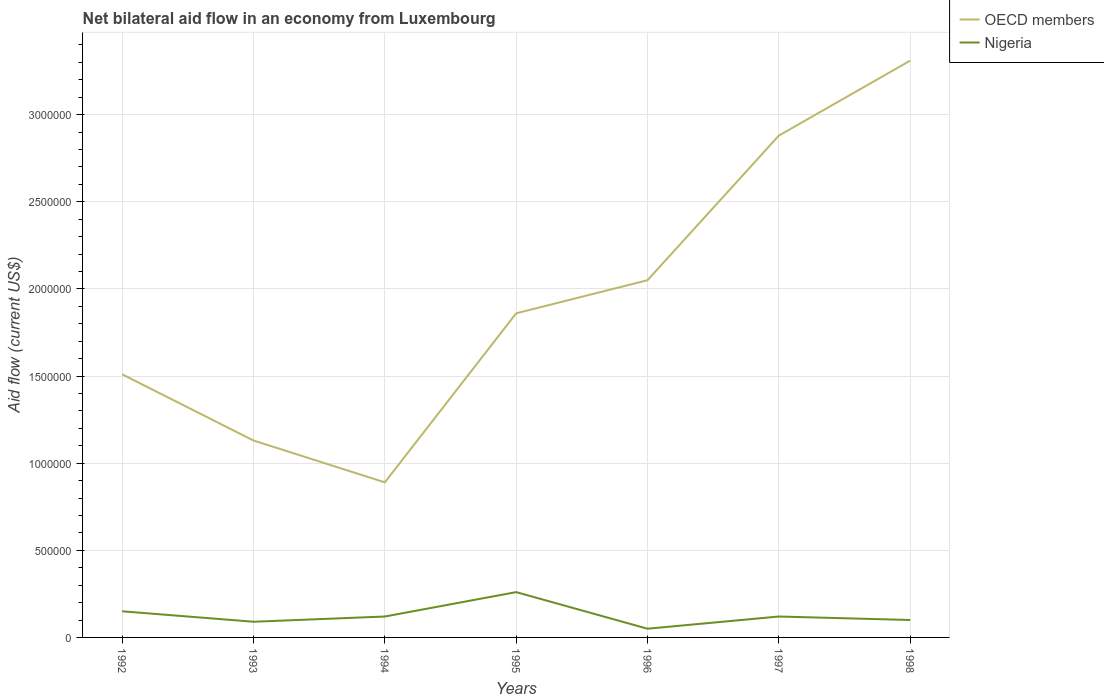How many different coloured lines are there?
Ensure brevity in your answer.  2. What is the total net bilateral aid flow in OECD members in the graph?
Make the answer very short. -1.99e+06. What is the difference between the highest and the second highest net bilateral aid flow in OECD members?
Keep it short and to the point. 2.42e+06. Is the net bilateral aid flow in OECD members strictly greater than the net bilateral aid flow in Nigeria over the years?
Offer a terse response. No. How many lines are there?
Ensure brevity in your answer.  2. Are the values on the major ticks of Y-axis written in scientific E-notation?
Provide a short and direct response. No. Does the graph contain any zero values?
Offer a terse response. No. Where does the legend appear in the graph?
Provide a succinct answer. Top right. How many legend labels are there?
Offer a terse response. 2. What is the title of the graph?
Provide a succinct answer. Net bilateral aid flow in an economy from Luxembourg. Does "Other small states" appear as one of the legend labels in the graph?
Your answer should be very brief. No. What is the label or title of the X-axis?
Offer a very short reply. Years. What is the label or title of the Y-axis?
Make the answer very short. Aid flow (current US$). What is the Aid flow (current US$) in OECD members in 1992?
Your answer should be compact. 1.51e+06. What is the Aid flow (current US$) of Nigeria in 1992?
Make the answer very short. 1.50e+05. What is the Aid flow (current US$) of OECD members in 1993?
Your answer should be very brief. 1.13e+06. What is the Aid flow (current US$) of Nigeria in 1993?
Keep it short and to the point. 9.00e+04. What is the Aid flow (current US$) of OECD members in 1994?
Provide a succinct answer. 8.90e+05. What is the Aid flow (current US$) of Nigeria in 1994?
Your answer should be compact. 1.20e+05. What is the Aid flow (current US$) of OECD members in 1995?
Ensure brevity in your answer.  1.86e+06. What is the Aid flow (current US$) in OECD members in 1996?
Provide a short and direct response. 2.05e+06. What is the Aid flow (current US$) of Nigeria in 1996?
Give a very brief answer. 5.00e+04. What is the Aid flow (current US$) of OECD members in 1997?
Offer a terse response. 2.88e+06. What is the Aid flow (current US$) in Nigeria in 1997?
Make the answer very short. 1.20e+05. What is the Aid flow (current US$) in OECD members in 1998?
Offer a terse response. 3.31e+06. What is the Aid flow (current US$) of Nigeria in 1998?
Ensure brevity in your answer.  1.00e+05. Across all years, what is the maximum Aid flow (current US$) of OECD members?
Your response must be concise. 3.31e+06. Across all years, what is the minimum Aid flow (current US$) in OECD members?
Offer a very short reply. 8.90e+05. Across all years, what is the minimum Aid flow (current US$) of Nigeria?
Keep it short and to the point. 5.00e+04. What is the total Aid flow (current US$) of OECD members in the graph?
Your answer should be very brief. 1.36e+07. What is the total Aid flow (current US$) in Nigeria in the graph?
Your answer should be very brief. 8.90e+05. What is the difference between the Aid flow (current US$) of OECD members in 1992 and that in 1994?
Offer a very short reply. 6.20e+05. What is the difference between the Aid flow (current US$) of OECD members in 1992 and that in 1995?
Your answer should be compact. -3.50e+05. What is the difference between the Aid flow (current US$) in Nigeria in 1992 and that in 1995?
Your answer should be compact. -1.10e+05. What is the difference between the Aid flow (current US$) in OECD members in 1992 and that in 1996?
Keep it short and to the point. -5.40e+05. What is the difference between the Aid flow (current US$) of OECD members in 1992 and that in 1997?
Ensure brevity in your answer.  -1.37e+06. What is the difference between the Aid flow (current US$) in OECD members in 1992 and that in 1998?
Make the answer very short. -1.80e+06. What is the difference between the Aid flow (current US$) of Nigeria in 1992 and that in 1998?
Offer a terse response. 5.00e+04. What is the difference between the Aid flow (current US$) of OECD members in 1993 and that in 1994?
Provide a short and direct response. 2.40e+05. What is the difference between the Aid flow (current US$) of OECD members in 1993 and that in 1995?
Make the answer very short. -7.30e+05. What is the difference between the Aid flow (current US$) in OECD members in 1993 and that in 1996?
Provide a short and direct response. -9.20e+05. What is the difference between the Aid flow (current US$) of OECD members in 1993 and that in 1997?
Offer a very short reply. -1.75e+06. What is the difference between the Aid flow (current US$) in Nigeria in 1993 and that in 1997?
Your response must be concise. -3.00e+04. What is the difference between the Aid flow (current US$) of OECD members in 1993 and that in 1998?
Provide a short and direct response. -2.18e+06. What is the difference between the Aid flow (current US$) of OECD members in 1994 and that in 1995?
Your answer should be compact. -9.70e+05. What is the difference between the Aid flow (current US$) in OECD members in 1994 and that in 1996?
Offer a very short reply. -1.16e+06. What is the difference between the Aid flow (current US$) in Nigeria in 1994 and that in 1996?
Provide a succinct answer. 7.00e+04. What is the difference between the Aid flow (current US$) in OECD members in 1994 and that in 1997?
Your answer should be very brief. -1.99e+06. What is the difference between the Aid flow (current US$) in OECD members in 1994 and that in 1998?
Ensure brevity in your answer.  -2.42e+06. What is the difference between the Aid flow (current US$) of Nigeria in 1994 and that in 1998?
Offer a very short reply. 2.00e+04. What is the difference between the Aid flow (current US$) of OECD members in 1995 and that in 1996?
Offer a very short reply. -1.90e+05. What is the difference between the Aid flow (current US$) of Nigeria in 1995 and that in 1996?
Provide a succinct answer. 2.10e+05. What is the difference between the Aid flow (current US$) of OECD members in 1995 and that in 1997?
Ensure brevity in your answer.  -1.02e+06. What is the difference between the Aid flow (current US$) in OECD members in 1995 and that in 1998?
Provide a short and direct response. -1.45e+06. What is the difference between the Aid flow (current US$) in OECD members in 1996 and that in 1997?
Provide a short and direct response. -8.30e+05. What is the difference between the Aid flow (current US$) of OECD members in 1996 and that in 1998?
Offer a very short reply. -1.26e+06. What is the difference between the Aid flow (current US$) in OECD members in 1997 and that in 1998?
Offer a very short reply. -4.30e+05. What is the difference between the Aid flow (current US$) in OECD members in 1992 and the Aid flow (current US$) in Nigeria in 1993?
Your response must be concise. 1.42e+06. What is the difference between the Aid flow (current US$) in OECD members in 1992 and the Aid flow (current US$) in Nigeria in 1994?
Provide a short and direct response. 1.39e+06. What is the difference between the Aid flow (current US$) of OECD members in 1992 and the Aid flow (current US$) of Nigeria in 1995?
Your answer should be compact. 1.25e+06. What is the difference between the Aid flow (current US$) of OECD members in 1992 and the Aid flow (current US$) of Nigeria in 1996?
Your answer should be compact. 1.46e+06. What is the difference between the Aid flow (current US$) of OECD members in 1992 and the Aid flow (current US$) of Nigeria in 1997?
Your answer should be very brief. 1.39e+06. What is the difference between the Aid flow (current US$) of OECD members in 1992 and the Aid flow (current US$) of Nigeria in 1998?
Offer a terse response. 1.41e+06. What is the difference between the Aid flow (current US$) in OECD members in 1993 and the Aid flow (current US$) in Nigeria in 1994?
Your response must be concise. 1.01e+06. What is the difference between the Aid flow (current US$) in OECD members in 1993 and the Aid flow (current US$) in Nigeria in 1995?
Offer a terse response. 8.70e+05. What is the difference between the Aid flow (current US$) in OECD members in 1993 and the Aid flow (current US$) in Nigeria in 1996?
Ensure brevity in your answer.  1.08e+06. What is the difference between the Aid flow (current US$) in OECD members in 1993 and the Aid flow (current US$) in Nigeria in 1997?
Offer a terse response. 1.01e+06. What is the difference between the Aid flow (current US$) of OECD members in 1993 and the Aid flow (current US$) of Nigeria in 1998?
Keep it short and to the point. 1.03e+06. What is the difference between the Aid flow (current US$) of OECD members in 1994 and the Aid flow (current US$) of Nigeria in 1995?
Keep it short and to the point. 6.30e+05. What is the difference between the Aid flow (current US$) of OECD members in 1994 and the Aid flow (current US$) of Nigeria in 1996?
Ensure brevity in your answer.  8.40e+05. What is the difference between the Aid flow (current US$) in OECD members in 1994 and the Aid flow (current US$) in Nigeria in 1997?
Your answer should be compact. 7.70e+05. What is the difference between the Aid flow (current US$) of OECD members in 1994 and the Aid flow (current US$) of Nigeria in 1998?
Your answer should be very brief. 7.90e+05. What is the difference between the Aid flow (current US$) in OECD members in 1995 and the Aid flow (current US$) in Nigeria in 1996?
Your response must be concise. 1.81e+06. What is the difference between the Aid flow (current US$) in OECD members in 1995 and the Aid flow (current US$) in Nigeria in 1997?
Provide a short and direct response. 1.74e+06. What is the difference between the Aid flow (current US$) in OECD members in 1995 and the Aid flow (current US$) in Nigeria in 1998?
Provide a short and direct response. 1.76e+06. What is the difference between the Aid flow (current US$) of OECD members in 1996 and the Aid flow (current US$) of Nigeria in 1997?
Keep it short and to the point. 1.93e+06. What is the difference between the Aid flow (current US$) in OECD members in 1996 and the Aid flow (current US$) in Nigeria in 1998?
Make the answer very short. 1.95e+06. What is the difference between the Aid flow (current US$) of OECD members in 1997 and the Aid flow (current US$) of Nigeria in 1998?
Offer a very short reply. 2.78e+06. What is the average Aid flow (current US$) of OECD members per year?
Make the answer very short. 1.95e+06. What is the average Aid flow (current US$) in Nigeria per year?
Make the answer very short. 1.27e+05. In the year 1992, what is the difference between the Aid flow (current US$) of OECD members and Aid flow (current US$) of Nigeria?
Your response must be concise. 1.36e+06. In the year 1993, what is the difference between the Aid flow (current US$) of OECD members and Aid flow (current US$) of Nigeria?
Your answer should be compact. 1.04e+06. In the year 1994, what is the difference between the Aid flow (current US$) in OECD members and Aid flow (current US$) in Nigeria?
Your response must be concise. 7.70e+05. In the year 1995, what is the difference between the Aid flow (current US$) of OECD members and Aid flow (current US$) of Nigeria?
Your answer should be very brief. 1.60e+06. In the year 1997, what is the difference between the Aid flow (current US$) of OECD members and Aid flow (current US$) of Nigeria?
Your response must be concise. 2.76e+06. In the year 1998, what is the difference between the Aid flow (current US$) of OECD members and Aid flow (current US$) of Nigeria?
Offer a very short reply. 3.21e+06. What is the ratio of the Aid flow (current US$) of OECD members in 1992 to that in 1993?
Your answer should be compact. 1.34. What is the ratio of the Aid flow (current US$) of OECD members in 1992 to that in 1994?
Your answer should be very brief. 1.7. What is the ratio of the Aid flow (current US$) of OECD members in 1992 to that in 1995?
Provide a succinct answer. 0.81. What is the ratio of the Aid flow (current US$) of Nigeria in 1992 to that in 1995?
Offer a very short reply. 0.58. What is the ratio of the Aid flow (current US$) of OECD members in 1992 to that in 1996?
Provide a succinct answer. 0.74. What is the ratio of the Aid flow (current US$) of Nigeria in 1992 to that in 1996?
Provide a succinct answer. 3. What is the ratio of the Aid flow (current US$) of OECD members in 1992 to that in 1997?
Your answer should be very brief. 0.52. What is the ratio of the Aid flow (current US$) of Nigeria in 1992 to that in 1997?
Your answer should be compact. 1.25. What is the ratio of the Aid flow (current US$) of OECD members in 1992 to that in 1998?
Your answer should be compact. 0.46. What is the ratio of the Aid flow (current US$) of OECD members in 1993 to that in 1994?
Your answer should be very brief. 1.27. What is the ratio of the Aid flow (current US$) in OECD members in 1993 to that in 1995?
Your answer should be very brief. 0.61. What is the ratio of the Aid flow (current US$) in Nigeria in 1993 to that in 1995?
Keep it short and to the point. 0.35. What is the ratio of the Aid flow (current US$) in OECD members in 1993 to that in 1996?
Your response must be concise. 0.55. What is the ratio of the Aid flow (current US$) in Nigeria in 1993 to that in 1996?
Your answer should be very brief. 1.8. What is the ratio of the Aid flow (current US$) of OECD members in 1993 to that in 1997?
Offer a very short reply. 0.39. What is the ratio of the Aid flow (current US$) of OECD members in 1993 to that in 1998?
Provide a short and direct response. 0.34. What is the ratio of the Aid flow (current US$) of OECD members in 1994 to that in 1995?
Your response must be concise. 0.48. What is the ratio of the Aid flow (current US$) in Nigeria in 1994 to that in 1995?
Your answer should be very brief. 0.46. What is the ratio of the Aid flow (current US$) in OECD members in 1994 to that in 1996?
Your answer should be compact. 0.43. What is the ratio of the Aid flow (current US$) in Nigeria in 1994 to that in 1996?
Keep it short and to the point. 2.4. What is the ratio of the Aid flow (current US$) of OECD members in 1994 to that in 1997?
Keep it short and to the point. 0.31. What is the ratio of the Aid flow (current US$) in Nigeria in 1994 to that in 1997?
Offer a terse response. 1. What is the ratio of the Aid flow (current US$) in OECD members in 1994 to that in 1998?
Your answer should be very brief. 0.27. What is the ratio of the Aid flow (current US$) in OECD members in 1995 to that in 1996?
Your response must be concise. 0.91. What is the ratio of the Aid flow (current US$) of OECD members in 1995 to that in 1997?
Offer a terse response. 0.65. What is the ratio of the Aid flow (current US$) in Nigeria in 1995 to that in 1997?
Give a very brief answer. 2.17. What is the ratio of the Aid flow (current US$) in OECD members in 1995 to that in 1998?
Provide a short and direct response. 0.56. What is the ratio of the Aid flow (current US$) of OECD members in 1996 to that in 1997?
Offer a very short reply. 0.71. What is the ratio of the Aid flow (current US$) in Nigeria in 1996 to that in 1997?
Keep it short and to the point. 0.42. What is the ratio of the Aid flow (current US$) in OECD members in 1996 to that in 1998?
Make the answer very short. 0.62. What is the ratio of the Aid flow (current US$) of Nigeria in 1996 to that in 1998?
Your answer should be compact. 0.5. What is the ratio of the Aid flow (current US$) of OECD members in 1997 to that in 1998?
Keep it short and to the point. 0.87. What is the ratio of the Aid flow (current US$) in Nigeria in 1997 to that in 1998?
Offer a terse response. 1.2. What is the difference between the highest and the second highest Aid flow (current US$) in Nigeria?
Ensure brevity in your answer.  1.10e+05. What is the difference between the highest and the lowest Aid flow (current US$) of OECD members?
Make the answer very short. 2.42e+06. What is the difference between the highest and the lowest Aid flow (current US$) in Nigeria?
Provide a short and direct response. 2.10e+05. 